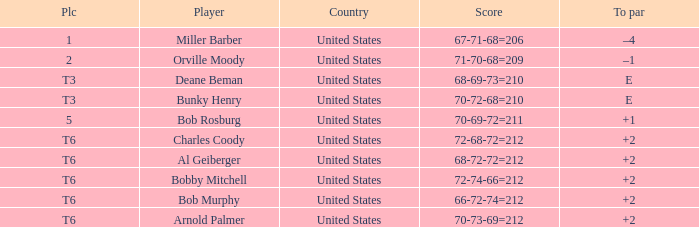What is the score of player bob rosburg? 70-69-72=211. 